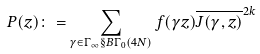<formula> <loc_0><loc_0><loc_500><loc_500>P ( z ) \colon = \sum _ { \gamma \in \Gamma _ { \infty } \S B \Gamma _ { 0 } ( 4 N ) } f ( \gamma z ) \overline { J ( \gamma , z ) } ^ { 2 k }</formula> 